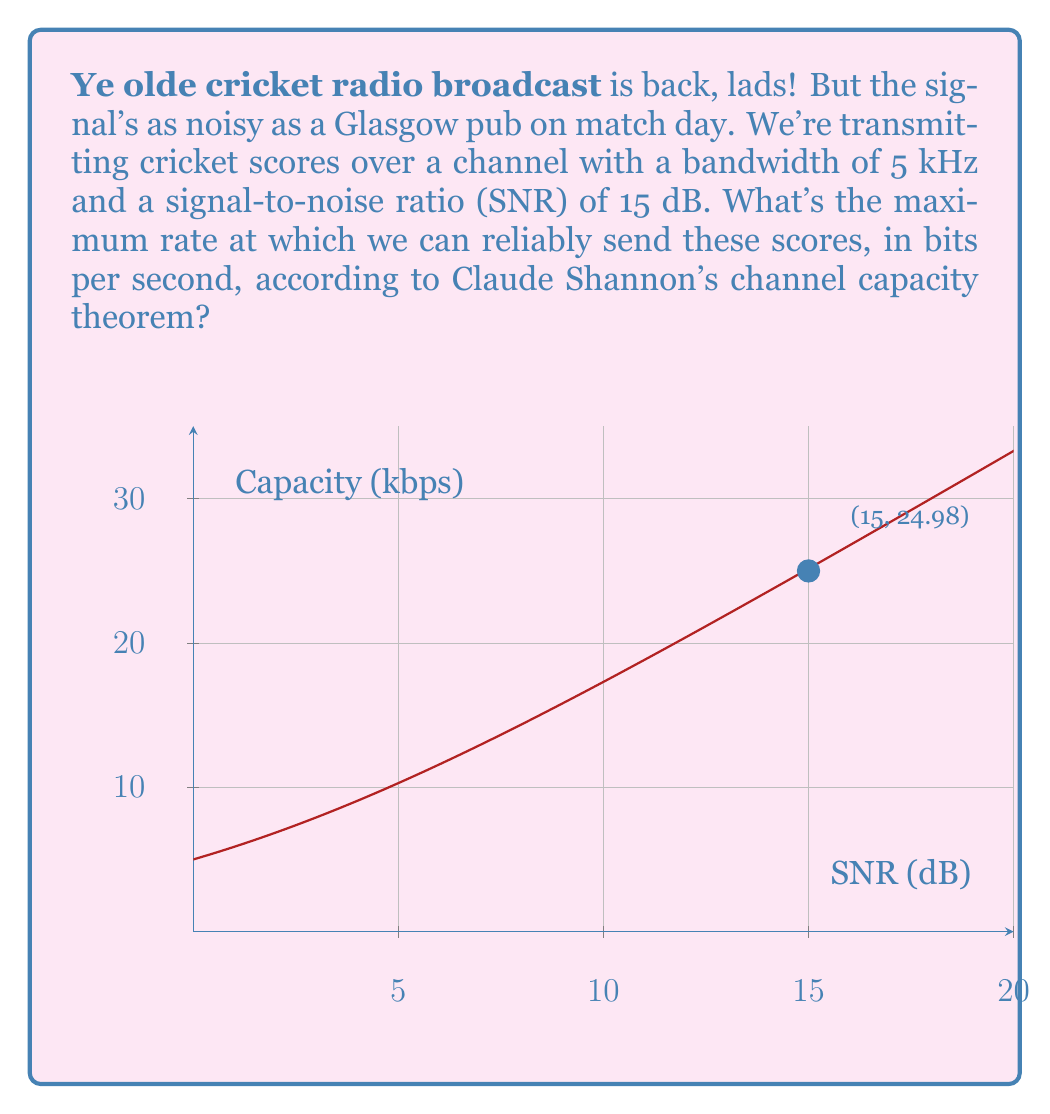Show me your answer to this math problem. Let's break this down, step by step, just like my grandad would explain a cricket match:

1) First, we need to recall Shannon's channel capacity formula:

   $$ C = B \log_2(1 + SNR) $$

   Where C is the channel capacity in bits per second, B is the bandwidth in Hz, and SNR is the signal-to-noise ratio.

2) We're given the bandwidth B = 5 kHz = 5000 Hz.

3) The SNR is given in decibels (dB). We need to convert this to a linear scale:

   $$ SNR_{linear} = 10^{SNR_{dB}/10} = 10^{15/10} = 10^{1.5} \approx 31.6228 $$

4) Now we can plug these values into Shannon's formula:

   $$ C = 5000 \log_2(1 + 31.6228) $$

5) Let's calculate this step by step:
   
   $$ C = 5000 \log_2(32.6228) $$
   $$ C = 5000 * 4.9975 $$
   $$ C = 24987.5 \text{ bits per second} $$

6) Rounding to two decimal places:

   $$ C \approx 24.99 \text{ kbps} $$

This means we can transmit cricket scores at a maximum rate of about 24.99 thousand bits per second, which should be plenty for even the most detailed commentary!
Answer: 24.99 kbps 